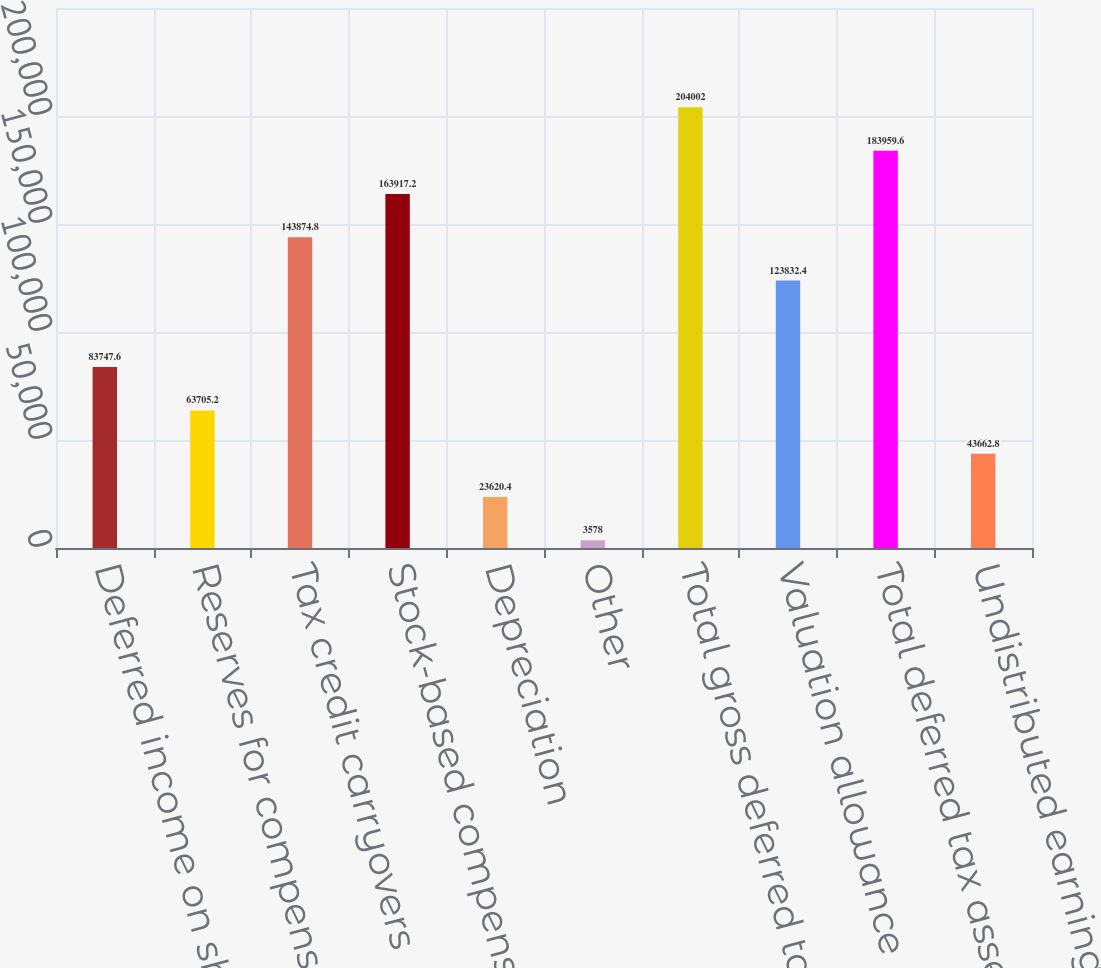Convert chart. <chart><loc_0><loc_0><loc_500><loc_500><bar_chart><fcel>Deferred income on shipments<fcel>Reserves for compensation and<fcel>Tax credit carryovers<fcel>Stock-based compensation<fcel>Depreciation<fcel>Other<fcel>Total gross deferred tax<fcel>Valuation allowance<fcel>Total deferred tax assets<fcel>Undistributed earnings of<nl><fcel>83747.6<fcel>63705.2<fcel>143875<fcel>163917<fcel>23620.4<fcel>3578<fcel>204002<fcel>123832<fcel>183960<fcel>43662.8<nl></chart> 